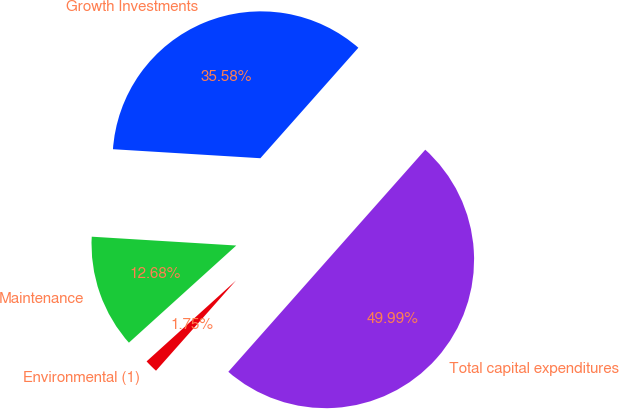<chart> <loc_0><loc_0><loc_500><loc_500><pie_chart><fcel>Growth Investments<fcel>Maintenance<fcel>Environmental (1)<fcel>Total capital expenditures<nl><fcel>35.58%<fcel>12.68%<fcel>1.75%<fcel>50.0%<nl></chart> 